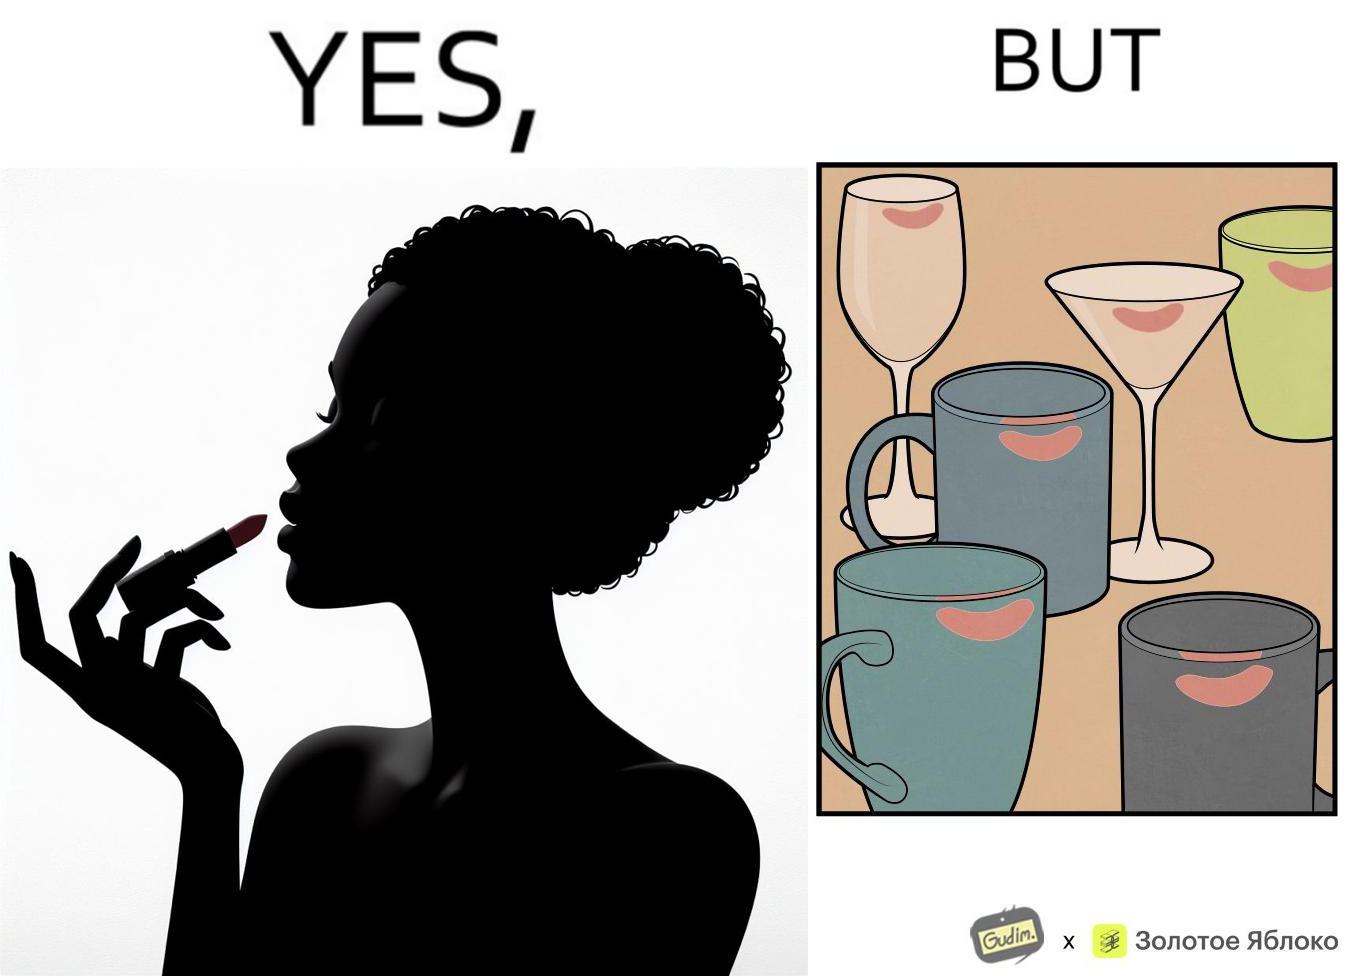What do you see in each half of this image? In the left part of the image: a person applying lipstick, probably a girl or woman In the right part of the image: lipstick stains on various mugs and glasses 